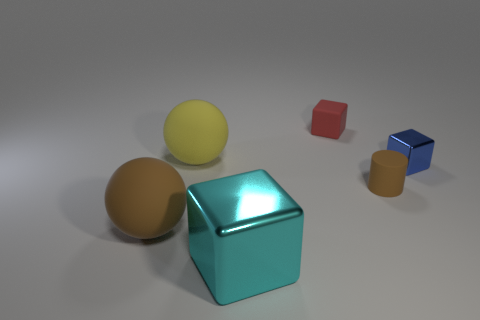Subtract all blue cubes. How many cubes are left? 2 Subtract all red blocks. How many blocks are left? 2 Subtract all spheres. How many objects are left? 4 Subtract 2 blocks. How many blocks are left? 1 Add 4 brown things. How many objects exist? 10 Subtract 0 brown blocks. How many objects are left? 6 Subtract all purple cubes. Subtract all brown cylinders. How many cubes are left? 3 Subtract all blue cylinders. How many yellow balls are left? 1 Subtract all big green shiny objects. Subtract all large brown rubber spheres. How many objects are left? 5 Add 3 big shiny things. How many big shiny things are left? 4 